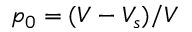Convert formula to latex. <formula><loc_0><loc_0><loc_500><loc_500>p _ { 0 } = ( V - V _ { s } ) / V</formula> 